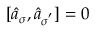Convert formula to latex. <formula><loc_0><loc_0><loc_500><loc_500>[ \hat { a } _ { \sigma } , \hat { a } _ { \sigma ^ { ^ { \prime } } } ] = 0</formula> 